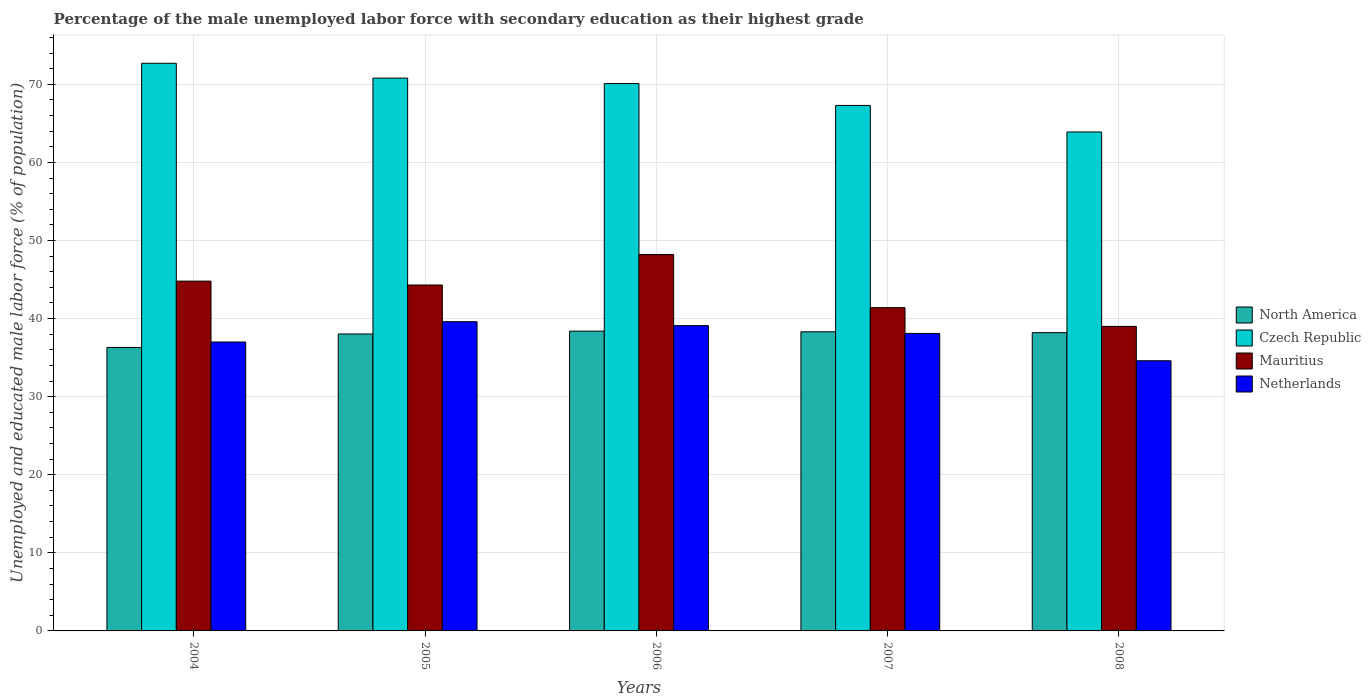Are the number of bars on each tick of the X-axis equal?
Keep it short and to the point. Yes. How many bars are there on the 5th tick from the left?
Offer a very short reply. 4. How many bars are there on the 1st tick from the right?
Your answer should be very brief. 4. What is the label of the 5th group of bars from the left?
Your response must be concise. 2008. In how many cases, is the number of bars for a given year not equal to the number of legend labels?
Offer a terse response. 0. What is the percentage of the unemployed male labor force with secondary education in Mauritius in 2007?
Your answer should be compact. 41.4. Across all years, what is the maximum percentage of the unemployed male labor force with secondary education in North America?
Ensure brevity in your answer.  38.39. Across all years, what is the minimum percentage of the unemployed male labor force with secondary education in Czech Republic?
Your answer should be compact. 63.9. In which year was the percentage of the unemployed male labor force with secondary education in Netherlands maximum?
Give a very brief answer. 2005. What is the total percentage of the unemployed male labor force with secondary education in North America in the graph?
Your response must be concise. 189.23. What is the difference between the percentage of the unemployed male labor force with secondary education in Czech Republic in 2008 and the percentage of the unemployed male labor force with secondary education in North America in 2005?
Provide a short and direct response. 25.87. What is the average percentage of the unemployed male labor force with secondary education in Netherlands per year?
Ensure brevity in your answer.  37.68. In the year 2008, what is the difference between the percentage of the unemployed male labor force with secondary education in North America and percentage of the unemployed male labor force with secondary education in Czech Republic?
Ensure brevity in your answer.  -25.7. What is the ratio of the percentage of the unemployed male labor force with secondary education in North America in 2006 to that in 2007?
Keep it short and to the point. 1. Is the difference between the percentage of the unemployed male labor force with secondary education in North America in 2005 and 2008 greater than the difference between the percentage of the unemployed male labor force with secondary education in Czech Republic in 2005 and 2008?
Ensure brevity in your answer.  No. What is the difference between the highest and the second highest percentage of the unemployed male labor force with secondary education in North America?
Give a very brief answer. 0.08. What is the difference between the highest and the lowest percentage of the unemployed male labor force with secondary education in Mauritius?
Your answer should be very brief. 9.2. Is the sum of the percentage of the unemployed male labor force with secondary education in Netherlands in 2005 and 2006 greater than the maximum percentage of the unemployed male labor force with secondary education in Czech Republic across all years?
Provide a short and direct response. Yes. What does the 1st bar from the left in 2008 represents?
Your answer should be compact. North America. Is it the case that in every year, the sum of the percentage of the unemployed male labor force with secondary education in Mauritius and percentage of the unemployed male labor force with secondary education in Czech Republic is greater than the percentage of the unemployed male labor force with secondary education in North America?
Provide a succinct answer. Yes. Are all the bars in the graph horizontal?
Offer a terse response. No. How many years are there in the graph?
Provide a succinct answer. 5. Does the graph contain grids?
Provide a short and direct response. Yes. How many legend labels are there?
Offer a very short reply. 4. How are the legend labels stacked?
Give a very brief answer. Vertical. What is the title of the graph?
Offer a very short reply. Percentage of the male unemployed labor force with secondary education as their highest grade. What is the label or title of the X-axis?
Your response must be concise. Years. What is the label or title of the Y-axis?
Make the answer very short. Unemployed and educated male labor force (% of population). What is the Unemployed and educated male labor force (% of population) of North America in 2004?
Offer a terse response. 36.3. What is the Unemployed and educated male labor force (% of population) of Czech Republic in 2004?
Offer a very short reply. 72.7. What is the Unemployed and educated male labor force (% of population) in Mauritius in 2004?
Keep it short and to the point. 44.8. What is the Unemployed and educated male labor force (% of population) of North America in 2005?
Offer a very short reply. 38.03. What is the Unemployed and educated male labor force (% of population) in Czech Republic in 2005?
Ensure brevity in your answer.  70.8. What is the Unemployed and educated male labor force (% of population) in Mauritius in 2005?
Your answer should be very brief. 44.3. What is the Unemployed and educated male labor force (% of population) in Netherlands in 2005?
Keep it short and to the point. 39.6. What is the Unemployed and educated male labor force (% of population) of North America in 2006?
Keep it short and to the point. 38.39. What is the Unemployed and educated male labor force (% of population) of Czech Republic in 2006?
Keep it short and to the point. 70.1. What is the Unemployed and educated male labor force (% of population) in Mauritius in 2006?
Provide a succinct answer. 48.2. What is the Unemployed and educated male labor force (% of population) in Netherlands in 2006?
Provide a succinct answer. 39.1. What is the Unemployed and educated male labor force (% of population) in North America in 2007?
Offer a terse response. 38.31. What is the Unemployed and educated male labor force (% of population) of Czech Republic in 2007?
Offer a very short reply. 67.3. What is the Unemployed and educated male labor force (% of population) in Mauritius in 2007?
Provide a succinct answer. 41.4. What is the Unemployed and educated male labor force (% of population) of Netherlands in 2007?
Offer a very short reply. 38.1. What is the Unemployed and educated male labor force (% of population) of North America in 2008?
Provide a short and direct response. 38.2. What is the Unemployed and educated male labor force (% of population) of Czech Republic in 2008?
Keep it short and to the point. 63.9. What is the Unemployed and educated male labor force (% of population) of Mauritius in 2008?
Give a very brief answer. 39. What is the Unemployed and educated male labor force (% of population) of Netherlands in 2008?
Ensure brevity in your answer.  34.6. Across all years, what is the maximum Unemployed and educated male labor force (% of population) in North America?
Make the answer very short. 38.39. Across all years, what is the maximum Unemployed and educated male labor force (% of population) in Czech Republic?
Offer a terse response. 72.7. Across all years, what is the maximum Unemployed and educated male labor force (% of population) of Mauritius?
Offer a terse response. 48.2. Across all years, what is the maximum Unemployed and educated male labor force (% of population) of Netherlands?
Your response must be concise. 39.6. Across all years, what is the minimum Unemployed and educated male labor force (% of population) in North America?
Make the answer very short. 36.3. Across all years, what is the minimum Unemployed and educated male labor force (% of population) in Czech Republic?
Give a very brief answer. 63.9. Across all years, what is the minimum Unemployed and educated male labor force (% of population) in Netherlands?
Provide a short and direct response. 34.6. What is the total Unemployed and educated male labor force (% of population) of North America in the graph?
Your answer should be very brief. 189.23. What is the total Unemployed and educated male labor force (% of population) in Czech Republic in the graph?
Give a very brief answer. 344.8. What is the total Unemployed and educated male labor force (% of population) of Mauritius in the graph?
Provide a succinct answer. 217.7. What is the total Unemployed and educated male labor force (% of population) of Netherlands in the graph?
Give a very brief answer. 188.4. What is the difference between the Unemployed and educated male labor force (% of population) in North America in 2004 and that in 2005?
Provide a succinct answer. -1.73. What is the difference between the Unemployed and educated male labor force (% of population) of Czech Republic in 2004 and that in 2005?
Provide a succinct answer. 1.9. What is the difference between the Unemployed and educated male labor force (% of population) in Mauritius in 2004 and that in 2005?
Provide a short and direct response. 0.5. What is the difference between the Unemployed and educated male labor force (% of population) in Netherlands in 2004 and that in 2005?
Your answer should be compact. -2.6. What is the difference between the Unemployed and educated male labor force (% of population) in North America in 2004 and that in 2006?
Ensure brevity in your answer.  -2.09. What is the difference between the Unemployed and educated male labor force (% of population) in North America in 2004 and that in 2007?
Give a very brief answer. -2.01. What is the difference between the Unemployed and educated male labor force (% of population) in North America in 2004 and that in 2008?
Provide a succinct answer. -1.89. What is the difference between the Unemployed and educated male labor force (% of population) of Czech Republic in 2004 and that in 2008?
Make the answer very short. 8.8. What is the difference between the Unemployed and educated male labor force (% of population) of Mauritius in 2004 and that in 2008?
Your answer should be very brief. 5.8. What is the difference between the Unemployed and educated male labor force (% of population) in North America in 2005 and that in 2006?
Provide a succinct answer. -0.36. What is the difference between the Unemployed and educated male labor force (% of population) in Mauritius in 2005 and that in 2006?
Your response must be concise. -3.9. What is the difference between the Unemployed and educated male labor force (% of population) of North America in 2005 and that in 2007?
Your answer should be very brief. -0.28. What is the difference between the Unemployed and educated male labor force (% of population) of Mauritius in 2005 and that in 2007?
Your answer should be very brief. 2.9. What is the difference between the Unemployed and educated male labor force (% of population) in North America in 2005 and that in 2008?
Provide a short and direct response. -0.17. What is the difference between the Unemployed and educated male labor force (% of population) of Mauritius in 2005 and that in 2008?
Your answer should be compact. 5.3. What is the difference between the Unemployed and educated male labor force (% of population) in North America in 2006 and that in 2007?
Your answer should be very brief. 0.08. What is the difference between the Unemployed and educated male labor force (% of population) of Netherlands in 2006 and that in 2007?
Provide a succinct answer. 1. What is the difference between the Unemployed and educated male labor force (% of population) in North America in 2006 and that in 2008?
Your response must be concise. 0.2. What is the difference between the Unemployed and educated male labor force (% of population) in Mauritius in 2006 and that in 2008?
Your answer should be very brief. 9.2. What is the difference between the Unemployed and educated male labor force (% of population) of North America in 2007 and that in 2008?
Give a very brief answer. 0.11. What is the difference between the Unemployed and educated male labor force (% of population) of Czech Republic in 2007 and that in 2008?
Keep it short and to the point. 3.4. What is the difference between the Unemployed and educated male labor force (% of population) of Netherlands in 2007 and that in 2008?
Make the answer very short. 3.5. What is the difference between the Unemployed and educated male labor force (% of population) in North America in 2004 and the Unemployed and educated male labor force (% of population) in Czech Republic in 2005?
Your answer should be compact. -34.5. What is the difference between the Unemployed and educated male labor force (% of population) in North America in 2004 and the Unemployed and educated male labor force (% of population) in Mauritius in 2005?
Your answer should be very brief. -8. What is the difference between the Unemployed and educated male labor force (% of population) in North America in 2004 and the Unemployed and educated male labor force (% of population) in Netherlands in 2005?
Your response must be concise. -3.3. What is the difference between the Unemployed and educated male labor force (% of population) in Czech Republic in 2004 and the Unemployed and educated male labor force (% of population) in Mauritius in 2005?
Keep it short and to the point. 28.4. What is the difference between the Unemployed and educated male labor force (% of population) in Czech Republic in 2004 and the Unemployed and educated male labor force (% of population) in Netherlands in 2005?
Your answer should be compact. 33.1. What is the difference between the Unemployed and educated male labor force (% of population) in Mauritius in 2004 and the Unemployed and educated male labor force (% of population) in Netherlands in 2005?
Offer a terse response. 5.2. What is the difference between the Unemployed and educated male labor force (% of population) in North America in 2004 and the Unemployed and educated male labor force (% of population) in Czech Republic in 2006?
Offer a very short reply. -33.8. What is the difference between the Unemployed and educated male labor force (% of population) of North America in 2004 and the Unemployed and educated male labor force (% of population) of Mauritius in 2006?
Ensure brevity in your answer.  -11.9. What is the difference between the Unemployed and educated male labor force (% of population) of North America in 2004 and the Unemployed and educated male labor force (% of population) of Netherlands in 2006?
Make the answer very short. -2.8. What is the difference between the Unemployed and educated male labor force (% of population) of Czech Republic in 2004 and the Unemployed and educated male labor force (% of population) of Netherlands in 2006?
Provide a short and direct response. 33.6. What is the difference between the Unemployed and educated male labor force (% of population) of Mauritius in 2004 and the Unemployed and educated male labor force (% of population) of Netherlands in 2006?
Keep it short and to the point. 5.7. What is the difference between the Unemployed and educated male labor force (% of population) of North America in 2004 and the Unemployed and educated male labor force (% of population) of Czech Republic in 2007?
Make the answer very short. -31. What is the difference between the Unemployed and educated male labor force (% of population) in North America in 2004 and the Unemployed and educated male labor force (% of population) in Mauritius in 2007?
Make the answer very short. -5.1. What is the difference between the Unemployed and educated male labor force (% of population) in North America in 2004 and the Unemployed and educated male labor force (% of population) in Netherlands in 2007?
Ensure brevity in your answer.  -1.8. What is the difference between the Unemployed and educated male labor force (% of population) in Czech Republic in 2004 and the Unemployed and educated male labor force (% of population) in Mauritius in 2007?
Offer a very short reply. 31.3. What is the difference between the Unemployed and educated male labor force (% of population) in Czech Republic in 2004 and the Unemployed and educated male labor force (% of population) in Netherlands in 2007?
Provide a short and direct response. 34.6. What is the difference between the Unemployed and educated male labor force (% of population) in Mauritius in 2004 and the Unemployed and educated male labor force (% of population) in Netherlands in 2007?
Provide a succinct answer. 6.7. What is the difference between the Unemployed and educated male labor force (% of population) of North America in 2004 and the Unemployed and educated male labor force (% of population) of Czech Republic in 2008?
Give a very brief answer. -27.6. What is the difference between the Unemployed and educated male labor force (% of population) of North America in 2004 and the Unemployed and educated male labor force (% of population) of Mauritius in 2008?
Your answer should be compact. -2.7. What is the difference between the Unemployed and educated male labor force (% of population) in North America in 2004 and the Unemployed and educated male labor force (% of population) in Netherlands in 2008?
Your answer should be very brief. 1.7. What is the difference between the Unemployed and educated male labor force (% of population) in Czech Republic in 2004 and the Unemployed and educated male labor force (% of population) in Mauritius in 2008?
Keep it short and to the point. 33.7. What is the difference between the Unemployed and educated male labor force (% of population) in Czech Republic in 2004 and the Unemployed and educated male labor force (% of population) in Netherlands in 2008?
Your answer should be very brief. 38.1. What is the difference between the Unemployed and educated male labor force (% of population) of Mauritius in 2004 and the Unemployed and educated male labor force (% of population) of Netherlands in 2008?
Give a very brief answer. 10.2. What is the difference between the Unemployed and educated male labor force (% of population) in North America in 2005 and the Unemployed and educated male labor force (% of population) in Czech Republic in 2006?
Offer a very short reply. -32.07. What is the difference between the Unemployed and educated male labor force (% of population) in North America in 2005 and the Unemployed and educated male labor force (% of population) in Mauritius in 2006?
Keep it short and to the point. -10.17. What is the difference between the Unemployed and educated male labor force (% of population) in North America in 2005 and the Unemployed and educated male labor force (% of population) in Netherlands in 2006?
Make the answer very short. -1.07. What is the difference between the Unemployed and educated male labor force (% of population) of Czech Republic in 2005 and the Unemployed and educated male labor force (% of population) of Mauritius in 2006?
Your answer should be very brief. 22.6. What is the difference between the Unemployed and educated male labor force (% of population) of Czech Republic in 2005 and the Unemployed and educated male labor force (% of population) of Netherlands in 2006?
Make the answer very short. 31.7. What is the difference between the Unemployed and educated male labor force (% of population) of Mauritius in 2005 and the Unemployed and educated male labor force (% of population) of Netherlands in 2006?
Offer a terse response. 5.2. What is the difference between the Unemployed and educated male labor force (% of population) in North America in 2005 and the Unemployed and educated male labor force (% of population) in Czech Republic in 2007?
Ensure brevity in your answer.  -29.27. What is the difference between the Unemployed and educated male labor force (% of population) of North America in 2005 and the Unemployed and educated male labor force (% of population) of Mauritius in 2007?
Make the answer very short. -3.37. What is the difference between the Unemployed and educated male labor force (% of population) in North America in 2005 and the Unemployed and educated male labor force (% of population) in Netherlands in 2007?
Your answer should be compact. -0.07. What is the difference between the Unemployed and educated male labor force (% of population) in Czech Republic in 2005 and the Unemployed and educated male labor force (% of population) in Mauritius in 2007?
Provide a succinct answer. 29.4. What is the difference between the Unemployed and educated male labor force (% of population) of Czech Republic in 2005 and the Unemployed and educated male labor force (% of population) of Netherlands in 2007?
Provide a short and direct response. 32.7. What is the difference between the Unemployed and educated male labor force (% of population) of Mauritius in 2005 and the Unemployed and educated male labor force (% of population) of Netherlands in 2007?
Your response must be concise. 6.2. What is the difference between the Unemployed and educated male labor force (% of population) in North America in 2005 and the Unemployed and educated male labor force (% of population) in Czech Republic in 2008?
Offer a terse response. -25.87. What is the difference between the Unemployed and educated male labor force (% of population) of North America in 2005 and the Unemployed and educated male labor force (% of population) of Mauritius in 2008?
Offer a very short reply. -0.97. What is the difference between the Unemployed and educated male labor force (% of population) of North America in 2005 and the Unemployed and educated male labor force (% of population) of Netherlands in 2008?
Provide a short and direct response. 3.43. What is the difference between the Unemployed and educated male labor force (% of population) of Czech Republic in 2005 and the Unemployed and educated male labor force (% of population) of Mauritius in 2008?
Your response must be concise. 31.8. What is the difference between the Unemployed and educated male labor force (% of population) in Czech Republic in 2005 and the Unemployed and educated male labor force (% of population) in Netherlands in 2008?
Your answer should be very brief. 36.2. What is the difference between the Unemployed and educated male labor force (% of population) in North America in 2006 and the Unemployed and educated male labor force (% of population) in Czech Republic in 2007?
Offer a very short reply. -28.91. What is the difference between the Unemployed and educated male labor force (% of population) in North America in 2006 and the Unemployed and educated male labor force (% of population) in Mauritius in 2007?
Your answer should be very brief. -3.01. What is the difference between the Unemployed and educated male labor force (% of population) in North America in 2006 and the Unemployed and educated male labor force (% of population) in Netherlands in 2007?
Keep it short and to the point. 0.29. What is the difference between the Unemployed and educated male labor force (% of population) of Czech Republic in 2006 and the Unemployed and educated male labor force (% of population) of Mauritius in 2007?
Make the answer very short. 28.7. What is the difference between the Unemployed and educated male labor force (% of population) in Mauritius in 2006 and the Unemployed and educated male labor force (% of population) in Netherlands in 2007?
Keep it short and to the point. 10.1. What is the difference between the Unemployed and educated male labor force (% of population) of North America in 2006 and the Unemployed and educated male labor force (% of population) of Czech Republic in 2008?
Ensure brevity in your answer.  -25.51. What is the difference between the Unemployed and educated male labor force (% of population) in North America in 2006 and the Unemployed and educated male labor force (% of population) in Mauritius in 2008?
Ensure brevity in your answer.  -0.61. What is the difference between the Unemployed and educated male labor force (% of population) in North America in 2006 and the Unemployed and educated male labor force (% of population) in Netherlands in 2008?
Offer a very short reply. 3.79. What is the difference between the Unemployed and educated male labor force (% of population) in Czech Republic in 2006 and the Unemployed and educated male labor force (% of population) in Mauritius in 2008?
Give a very brief answer. 31.1. What is the difference between the Unemployed and educated male labor force (% of population) in Czech Republic in 2006 and the Unemployed and educated male labor force (% of population) in Netherlands in 2008?
Provide a short and direct response. 35.5. What is the difference between the Unemployed and educated male labor force (% of population) in Mauritius in 2006 and the Unemployed and educated male labor force (% of population) in Netherlands in 2008?
Your response must be concise. 13.6. What is the difference between the Unemployed and educated male labor force (% of population) of North America in 2007 and the Unemployed and educated male labor force (% of population) of Czech Republic in 2008?
Keep it short and to the point. -25.59. What is the difference between the Unemployed and educated male labor force (% of population) in North America in 2007 and the Unemployed and educated male labor force (% of population) in Mauritius in 2008?
Make the answer very short. -0.69. What is the difference between the Unemployed and educated male labor force (% of population) of North America in 2007 and the Unemployed and educated male labor force (% of population) of Netherlands in 2008?
Your answer should be very brief. 3.71. What is the difference between the Unemployed and educated male labor force (% of population) in Czech Republic in 2007 and the Unemployed and educated male labor force (% of population) in Mauritius in 2008?
Offer a terse response. 28.3. What is the difference between the Unemployed and educated male labor force (% of population) in Czech Republic in 2007 and the Unemployed and educated male labor force (% of population) in Netherlands in 2008?
Your answer should be compact. 32.7. What is the average Unemployed and educated male labor force (% of population) of North America per year?
Provide a succinct answer. 37.85. What is the average Unemployed and educated male labor force (% of population) in Czech Republic per year?
Provide a succinct answer. 68.96. What is the average Unemployed and educated male labor force (% of population) in Mauritius per year?
Provide a short and direct response. 43.54. What is the average Unemployed and educated male labor force (% of population) of Netherlands per year?
Offer a very short reply. 37.68. In the year 2004, what is the difference between the Unemployed and educated male labor force (% of population) in North America and Unemployed and educated male labor force (% of population) in Czech Republic?
Ensure brevity in your answer.  -36.4. In the year 2004, what is the difference between the Unemployed and educated male labor force (% of population) in North America and Unemployed and educated male labor force (% of population) in Mauritius?
Offer a very short reply. -8.5. In the year 2004, what is the difference between the Unemployed and educated male labor force (% of population) of North America and Unemployed and educated male labor force (% of population) of Netherlands?
Give a very brief answer. -0.7. In the year 2004, what is the difference between the Unemployed and educated male labor force (% of population) of Czech Republic and Unemployed and educated male labor force (% of population) of Mauritius?
Your response must be concise. 27.9. In the year 2004, what is the difference between the Unemployed and educated male labor force (% of population) of Czech Republic and Unemployed and educated male labor force (% of population) of Netherlands?
Ensure brevity in your answer.  35.7. In the year 2004, what is the difference between the Unemployed and educated male labor force (% of population) of Mauritius and Unemployed and educated male labor force (% of population) of Netherlands?
Give a very brief answer. 7.8. In the year 2005, what is the difference between the Unemployed and educated male labor force (% of population) of North America and Unemployed and educated male labor force (% of population) of Czech Republic?
Offer a very short reply. -32.77. In the year 2005, what is the difference between the Unemployed and educated male labor force (% of population) in North America and Unemployed and educated male labor force (% of population) in Mauritius?
Give a very brief answer. -6.27. In the year 2005, what is the difference between the Unemployed and educated male labor force (% of population) in North America and Unemployed and educated male labor force (% of population) in Netherlands?
Your answer should be compact. -1.57. In the year 2005, what is the difference between the Unemployed and educated male labor force (% of population) in Czech Republic and Unemployed and educated male labor force (% of population) in Mauritius?
Give a very brief answer. 26.5. In the year 2005, what is the difference between the Unemployed and educated male labor force (% of population) of Czech Republic and Unemployed and educated male labor force (% of population) of Netherlands?
Provide a succinct answer. 31.2. In the year 2005, what is the difference between the Unemployed and educated male labor force (% of population) in Mauritius and Unemployed and educated male labor force (% of population) in Netherlands?
Your answer should be compact. 4.7. In the year 2006, what is the difference between the Unemployed and educated male labor force (% of population) of North America and Unemployed and educated male labor force (% of population) of Czech Republic?
Your response must be concise. -31.71. In the year 2006, what is the difference between the Unemployed and educated male labor force (% of population) of North America and Unemployed and educated male labor force (% of population) of Mauritius?
Provide a short and direct response. -9.81. In the year 2006, what is the difference between the Unemployed and educated male labor force (% of population) in North America and Unemployed and educated male labor force (% of population) in Netherlands?
Offer a very short reply. -0.71. In the year 2006, what is the difference between the Unemployed and educated male labor force (% of population) of Czech Republic and Unemployed and educated male labor force (% of population) of Mauritius?
Ensure brevity in your answer.  21.9. In the year 2007, what is the difference between the Unemployed and educated male labor force (% of population) of North America and Unemployed and educated male labor force (% of population) of Czech Republic?
Your response must be concise. -28.99. In the year 2007, what is the difference between the Unemployed and educated male labor force (% of population) of North America and Unemployed and educated male labor force (% of population) of Mauritius?
Provide a succinct answer. -3.09. In the year 2007, what is the difference between the Unemployed and educated male labor force (% of population) in North America and Unemployed and educated male labor force (% of population) in Netherlands?
Your answer should be very brief. 0.21. In the year 2007, what is the difference between the Unemployed and educated male labor force (% of population) of Czech Republic and Unemployed and educated male labor force (% of population) of Mauritius?
Offer a very short reply. 25.9. In the year 2007, what is the difference between the Unemployed and educated male labor force (% of population) in Czech Republic and Unemployed and educated male labor force (% of population) in Netherlands?
Keep it short and to the point. 29.2. In the year 2008, what is the difference between the Unemployed and educated male labor force (% of population) in North America and Unemployed and educated male labor force (% of population) in Czech Republic?
Your response must be concise. -25.7. In the year 2008, what is the difference between the Unemployed and educated male labor force (% of population) in North America and Unemployed and educated male labor force (% of population) in Mauritius?
Give a very brief answer. -0.8. In the year 2008, what is the difference between the Unemployed and educated male labor force (% of population) in North America and Unemployed and educated male labor force (% of population) in Netherlands?
Provide a succinct answer. 3.6. In the year 2008, what is the difference between the Unemployed and educated male labor force (% of population) of Czech Republic and Unemployed and educated male labor force (% of population) of Mauritius?
Keep it short and to the point. 24.9. In the year 2008, what is the difference between the Unemployed and educated male labor force (% of population) of Czech Republic and Unemployed and educated male labor force (% of population) of Netherlands?
Ensure brevity in your answer.  29.3. In the year 2008, what is the difference between the Unemployed and educated male labor force (% of population) of Mauritius and Unemployed and educated male labor force (% of population) of Netherlands?
Your answer should be compact. 4.4. What is the ratio of the Unemployed and educated male labor force (% of population) of North America in 2004 to that in 2005?
Offer a very short reply. 0.95. What is the ratio of the Unemployed and educated male labor force (% of population) of Czech Republic in 2004 to that in 2005?
Provide a succinct answer. 1.03. What is the ratio of the Unemployed and educated male labor force (% of population) in Mauritius in 2004 to that in 2005?
Provide a succinct answer. 1.01. What is the ratio of the Unemployed and educated male labor force (% of population) in Netherlands in 2004 to that in 2005?
Give a very brief answer. 0.93. What is the ratio of the Unemployed and educated male labor force (% of population) of North America in 2004 to that in 2006?
Your answer should be very brief. 0.95. What is the ratio of the Unemployed and educated male labor force (% of population) of Czech Republic in 2004 to that in 2006?
Give a very brief answer. 1.04. What is the ratio of the Unemployed and educated male labor force (% of population) in Mauritius in 2004 to that in 2006?
Your answer should be very brief. 0.93. What is the ratio of the Unemployed and educated male labor force (% of population) in Netherlands in 2004 to that in 2006?
Offer a very short reply. 0.95. What is the ratio of the Unemployed and educated male labor force (% of population) of North America in 2004 to that in 2007?
Give a very brief answer. 0.95. What is the ratio of the Unemployed and educated male labor force (% of population) in Czech Republic in 2004 to that in 2007?
Keep it short and to the point. 1.08. What is the ratio of the Unemployed and educated male labor force (% of population) in Mauritius in 2004 to that in 2007?
Ensure brevity in your answer.  1.08. What is the ratio of the Unemployed and educated male labor force (% of population) in Netherlands in 2004 to that in 2007?
Give a very brief answer. 0.97. What is the ratio of the Unemployed and educated male labor force (% of population) of North America in 2004 to that in 2008?
Your answer should be very brief. 0.95. What is the ratio of the Unemployed and educated male labor force (% of population) of Czech Republic in 2004 to that in 2008?
Make the answer very short. 1.14. What is the ratio of the Unemployed and educated male labor force (% of population) in Mauritius in 2004 to that in 2008?
Offer a very short reply. 1.15. What is the ratio of the Unemployed and educated male labor force (% of population) in Netherlands in 2004 to that in 2008?
Make the answer very short. 1.07. What is the ratio of the Unemployed and educated male labor force (% of population) of Mauritius in 2005 to that in 2006?
Offer a very short reply. 0.92. What is the ratio of the Unemployed and educated male labor force (% of population) of Netherlands in 2005 to that in 2006?
Provide a succinct answer. 1.01. What is the ratio of the Unemployed and educated male labor force (% of population) in North America in 2005 to that in 2007?
Provide a succinct answer. 0.99. What is the ratio of the Unemployed and educated male labor force (% of population) in Czech Republic in 2005 to that in 2007?
Your answer should be very brief. 1.05. What is the ratio of the Unemployed and educated male labor force (% of population) in Mauritius in 2005 to that in 2007?
Offer a terse response. 1.07. What is the ratio of the Unemployed and educated male labor force (% of population) of Netherlands in 2005 to that in 2007?
Ensure brevity in your answer.  1.04. What is the ratio of the Unemployed and educated male labor force (% of population) in Czech Republic in 2005 to that in 2008?
Keep it short and to the point. 1.11. What is the ratio of the Unemployed and educated male labor force (% of population) in Mauritius in 2005 to that in 2008?
Make the answer very short. 1.14. What is the ratio of the Unemployed and educated male labor force (% of population) of Netherlands in 2005 to that in 2008?
Your answer should be compact. 1.14. What is the ratio of the Unemployed and educated male labor force (% of population) in North America in 2006 to that in 2007?
Your answer should be very brief. 1. What is the ratio of the Unemployed and educated male labor force (% of population) in Czech Republic in 2006 to that in 2007?
Make the answer very short. 1.04. What is the ratio of the Unemployed and educated male labor force (% of population) of Mauritius in 2006 to that in 2007?
Offer a very short reply. 1.16. What is the ratio of the Unemployed and educated male labor force (% of population) in Netherlands in 2006 to that in 2007?
Your response must be concise. 1.03. What is the ratio of the Unemployed and educated male labor force (% of population) of North America in 2006 to that in 2008?
Offer a terse response. 1.01. What is the ratio of the Unemployed and educated male labor force (% of population) of Czech Republic in 2006 to that in 2008?
Provide a short and direct response. 1.1. What is the ratio of the Unemployed and educated male labor force (% of population) in Mauritius in 2006 to that in 2008?
Provide a short and direct response. 1.24. What is the ratio of the Unemployed and educated male labor force (% of population) of Netherlands in 2006 to that in 2008?
Ensure brevity in your answer.  1.13. What is the ratio of the Unemployed and educated male labor force (% of population) of Czech Republic in 2007 to that in 2008?
Provide a succinct answer. 1.05. What is the ratio of the Unemployed and educated male labor force (% of population) of Mauritius in 2007 to that in 2008?
Your response must be concise. 1.06. What is the ratio of the Unemployed and educated male labor force (% of population) in Netherlands in 2007 to that in 2008?
Your response must be concise. 1.1. What is the difference between the highest and the second highest Unemployed and educated male labor force (% of population) of North America?
Offer a terse response. 0.08. What is the difference between the highest and the second highest Unemployed and educated male labor force (% of population) of Czech Republic?
Keep it short and to the point. 1.9. What is the difference between the highest and the second highest Unemployed and educated male labor force (% of population) of Mauritius?
Offer a very short reply. 3.4. What is the difference between the highest and the lowest Unemployed and educated male labor force (% of population) in North America?
Your answer should be compact. 2.09. What is the difference between the highest and the lowest Unemployed and educated male labor force (% of population) in Czech Republic?
Keep it short and to the point. 8.8. What is the difference between the highest and the lowest Unemployed and educated male labor force (% of population) in Mauritius?
Ensure brevity in your answer.  9.2. 